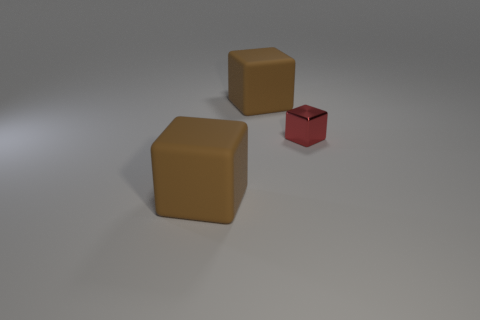There is a tiny shiny object; how many big matte blocks are in front of it?
Your response must be concise. 1. How many metallic objects are there?
Ensure brevity in your answer.  1. There is a big matte thing in front of the red cube; what color is it?
Offer a terse response. Brown. What is the size of the metal block?
Ensure brevity in your answer.  Small. Does the shiny cube have the same color as the large thing in front of the tiny red shiny cube?
Provide a short and direct response. No. What color is the tiny metallic object that is behind the big block in front of the tiny shiny block?
Your answer should be compact. Red. Is there anything else that has the same size as the red thing?
Provide a succinct answer. No. There is a big object behind the metallic block; does it have the same shape as the small object?
Your answer should be very brief. Yes. The metallic thing to the right of the matte object that is right of the large brown cube in front of the tiny object is what color?
Make the answer very short. Red. There is a large brown thing that is behind the tiny red shiny thing; what number of tiny metallic cubes are to the left of it?
Your answer should be compact. 0. 